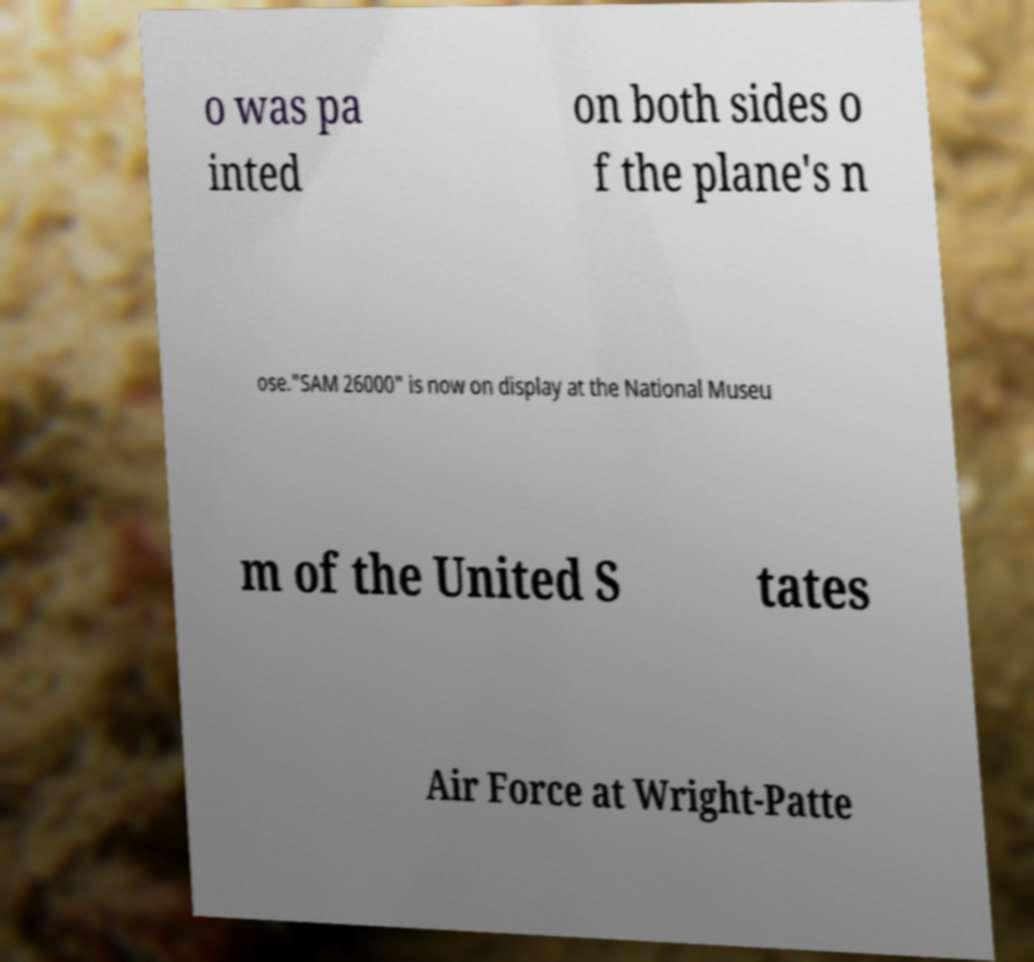Please read and relay the text visible in this image. What does it say? o was pa inted on both sides o f the plane's n ose."SAM 26000" is now on display at the National Museu m of the United S tates Air Force at Wright-Patte 